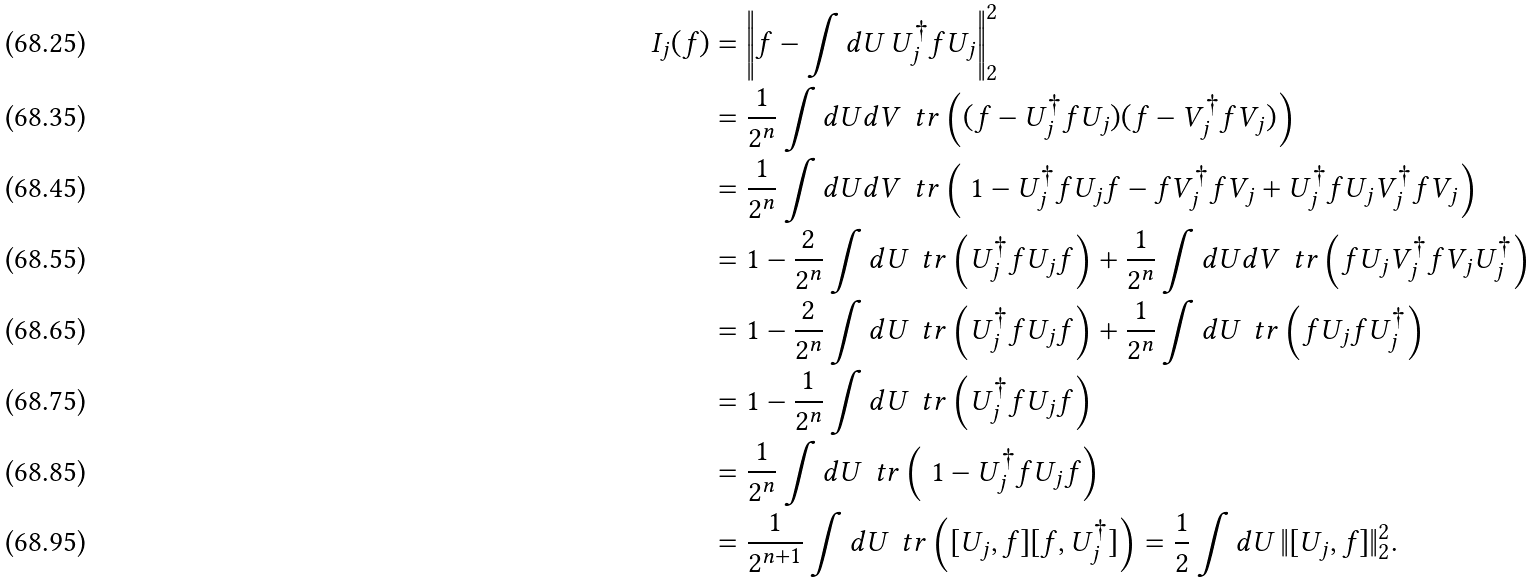<formula> <loc_0><loc_0><loc_500><loc_500>I _ { j } ( f ) & = \left \| f - \int d U \, U _ { j } ^ { \dag } f U _ { j } \right \| _ { 2 } ^ { 2 } \\ & = \frac { 1 } { 2 ^ { n } } \int d U d V \, \ t r \left ( ( f - U _ { j } ^ { \dag } f U _ { j } ) ( f - V _ { j } ^ { \dag } f V _ { j } ) \right ) \\ & = \frac { 1 } { 2 ^ { n } } \int d U d V \, \ t r \left ( \ 1 - U _ { j } ^ { \dag } f U _ { j } f - f V _ { j } ^ { \dag } f V _ { j } + U _ { j } ^ { \dag } f U _ { j } V _ { j } ^ { \dag } f V _ { j } \right ) \\ & = 1 - \frac { 2 } { 2 ^ { n } } \int d U \, \ t r \left ( U _ { j } ^ { \dag } f U _ { j } f \right ) + \frac { 1 } { 2 ^ { n } } \int d U d V \, \ t r \left ( f U _ { j } V _ { j } ^ { \dag } f V _ { j } U _ { j } ^ { \dag } \right ) \\ & = 1 - \frac { 2 } { 2 ^ { n } } \int d U \, \ t r \left ( U _ { j } ^ { \dag } f U _ { j } f \right ) + \frac { 1 } { 2 ^ { n } } \int d U \, \ t r \left ( f U _ { j } f U _ { j } ^ { \dag } \right ) \\ & = 1 - \frac { 1 } { 2 ^ { n } } \int d U \, \ t r \left ( U _ { j } ^ { \dag } f U _ { j } f \right ) \\ & = \frac { 1 } { 2 ^ { n } } \int d U \, \ t r \left ( \ 1 - U _ { j } ^ { \dag } f U _ { j } f \right ) \\ & = \frac { 1 } { 2 ^ { n + 1 } } \int d U \, \ t r \left ( [ U _ { j } , f ] [ f , U _ { j } ^ { \dag } ] \right ) = \frac { 1 } { 2 } \int d U \, \| [ U _ { j } , f ] \| _ { 2 } ^ { 2 } .</formula> 